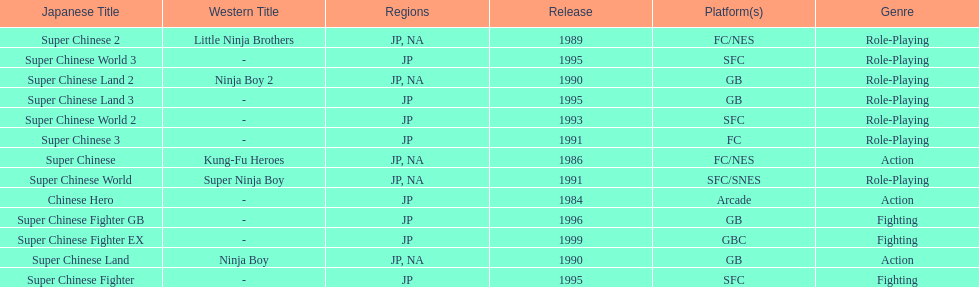The first year a game was released in north america 1986. 